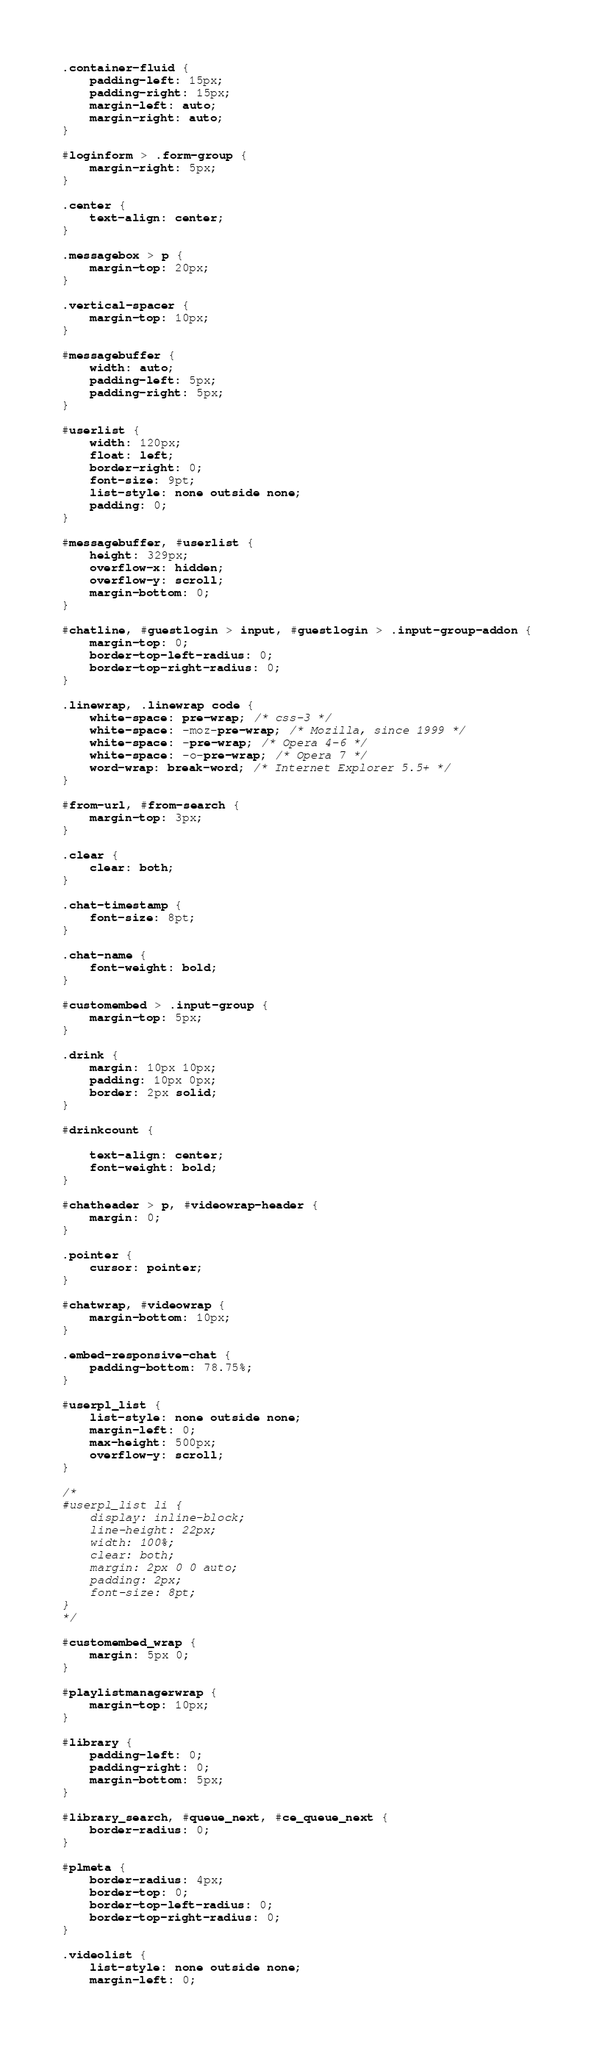<code> <loc_0><loc_0><loc_500><loc_500><_CSS_>
.container-fluid {
    padding-left: 15px;
    padding-right: 15px;
    margin-left: auto;
    margin-right: auto;
}

#loginform > .form-group {
    margin-right: 5px;
}

.center {
    text-align: center;
}

.messagebox > p {
    margin-top: 20px;
}

.vertical-spacer {
    margin-top: 10px;
}

#messagebuffer {
    width: auto;
    padding-left: 5px;
    padding-right: 5px;
}

#userlist {
    width: 120px;
    float: left;
    border-right: 0;
    font-size: 9pt;
    list-style: none outside none;
    padding: 0;
}

#messagebuffer, #userlist {
    height: 329px;
    overflow-x: hidden;
    overflow-y: scroll;
    margin-bottom: 0;
}

#chatline, #guestlogin > input, #guestlogin > .input-group-addon {
    margin-top: 0;
    border-top-left-radius: 0;
    border-top-right-radius: 0;
}

.linewrap, .linewrap code {
    white-space: pre-wrap; /* css-3 */
    white-space: -moz-pre-wrap; /* Mozilla, since 1999 */
    white-space: -pre-wrap; /* Opera 4-6 */
    white-space: -o-pre-wrap; /* Opera 7 */
    word-wrap: break-word; /* Internet Explorer 5.5+ */
}

#from-url, #from-search {
    margin-top: 3px;
}

.clear {
    clear: both;
}

.chat-timestamp {
    font-size: 8pt;
}

.chat-name {
    font-weight: bold;
}

#customembed > .input-group {
    margin-top: 5px;
}

.drink {
    margin: 10px 10px;
    padding: 10px 0px;
    border: 2px solid;
}

#drinkcount {

    text-align: center;
    font-weight: bold;
}

#chatheader > p, #videowrap-header {
    margin: 0;
}

.pointer {
    cursor: pointer;
}

#chatwrap, #videowrap {
    margin-bottom: 10px;
}

.embed-responsive-chat {
    padding-bottom: 78.75%;
}

#userpl_list {
    list-style: none outside none;
    margin-left: 0;
    max-height: 500px;
    overflow-y: scroll;
}

/*
#userpl_list li {
    display: inline-block;
    line-height: 22px;
    width: 100%;
    clear: both;
    margin: 2px 0 0 auto;
    padding: 2px;
    font-size: 8pt;
}
*/

#customembed_wrap {
    margin: 5px 0;
}

#playlistmanagerwrap {
    margin-top: 10px;
}

#library {
    padding-left: 0;
    padding-right: 0;
    margin-bottom: 5px;
}

#library_search, #queue_next, #ce_queue_next {
    border-radius: 0;
}

#plmeta {
    border-radius: 4px;
    border-top: 0;
    border-top-left-radius: 0;
    border-top-right-radius: 0;
}

.videolist {
    list-style: none outside none;
    margin-left: 0;</code> 